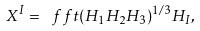<formula> <loc_0><loc_0><loc_500><loc_500>X ^ { I } = \ f f t { ( H _ { 1 } H _ { 2 } H _ { 3 } ) ^ { 1 / 3 } } { H _ { I } } ,</formula> 